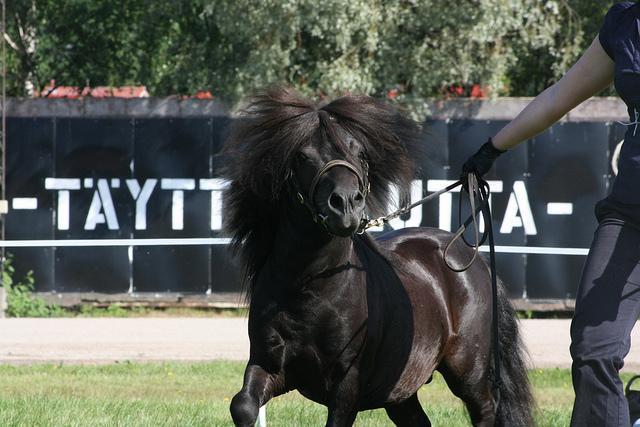How many motorcycles have an american flag on them?
Give a very brief answer. 0. 